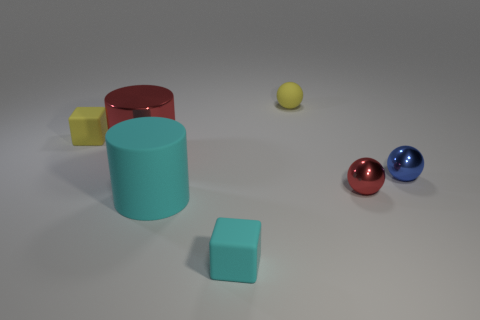Subtract all yellow blocks. Subtract all red spheres. How many blocks are left? 1 Add 1 big brown matte blocks. How many objects exist? 8 Subtract all cubes. How many objects are left? 5 Add 1 small cyan cylinders. How many small cyan cylinders exist? 1 Subtract 0 blue cylinders. How many objects are left? 7 Subtract all yellow balls. Subtract all red blocks. How many objects are left? 6 Add 1 red shiny spheres. How many red shiny spheres are left? 2 